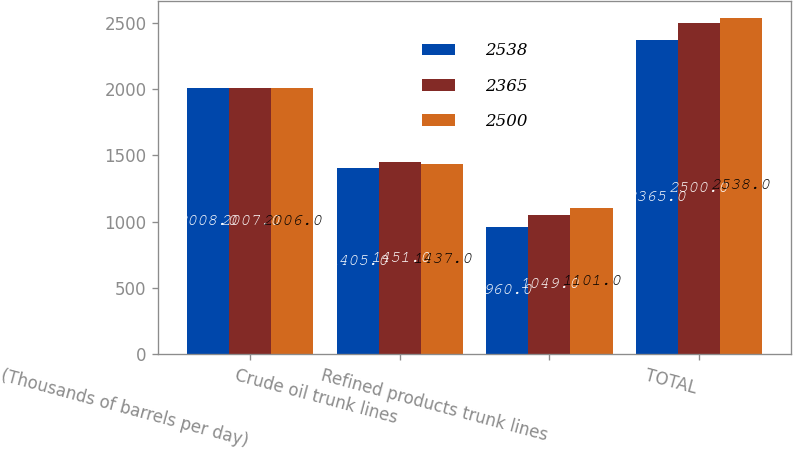Convert chart to OTSL. <chart><loc_0><loc_0><loc_500><loc_500><stacked_bar_chart><ecel><fcel>(Thousands of barrels per day)<fcel>Crude oil trunk lines<fcel>Refined products trunk lines<fcel>TOTAL<nl><fcel>2538<fcel>2008<fcel>1405<fcel>960<fcel>2365<nl><fcel>2365<fcel>2007<fcel>1451<fcel>1049<fcel>2500<nl><fcel>2500<fcel>2006<fcel>1437<fcel>1101<fcel>2538<nl></chart> 